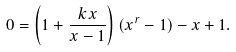<formula> <loc_0><loc_0><loc_500><loc_500>0 = \left ( 1 + \frac { k x } { x - 1 } \right ) ( x ^ { r } - 1 ) - x + 1 .</formula> 